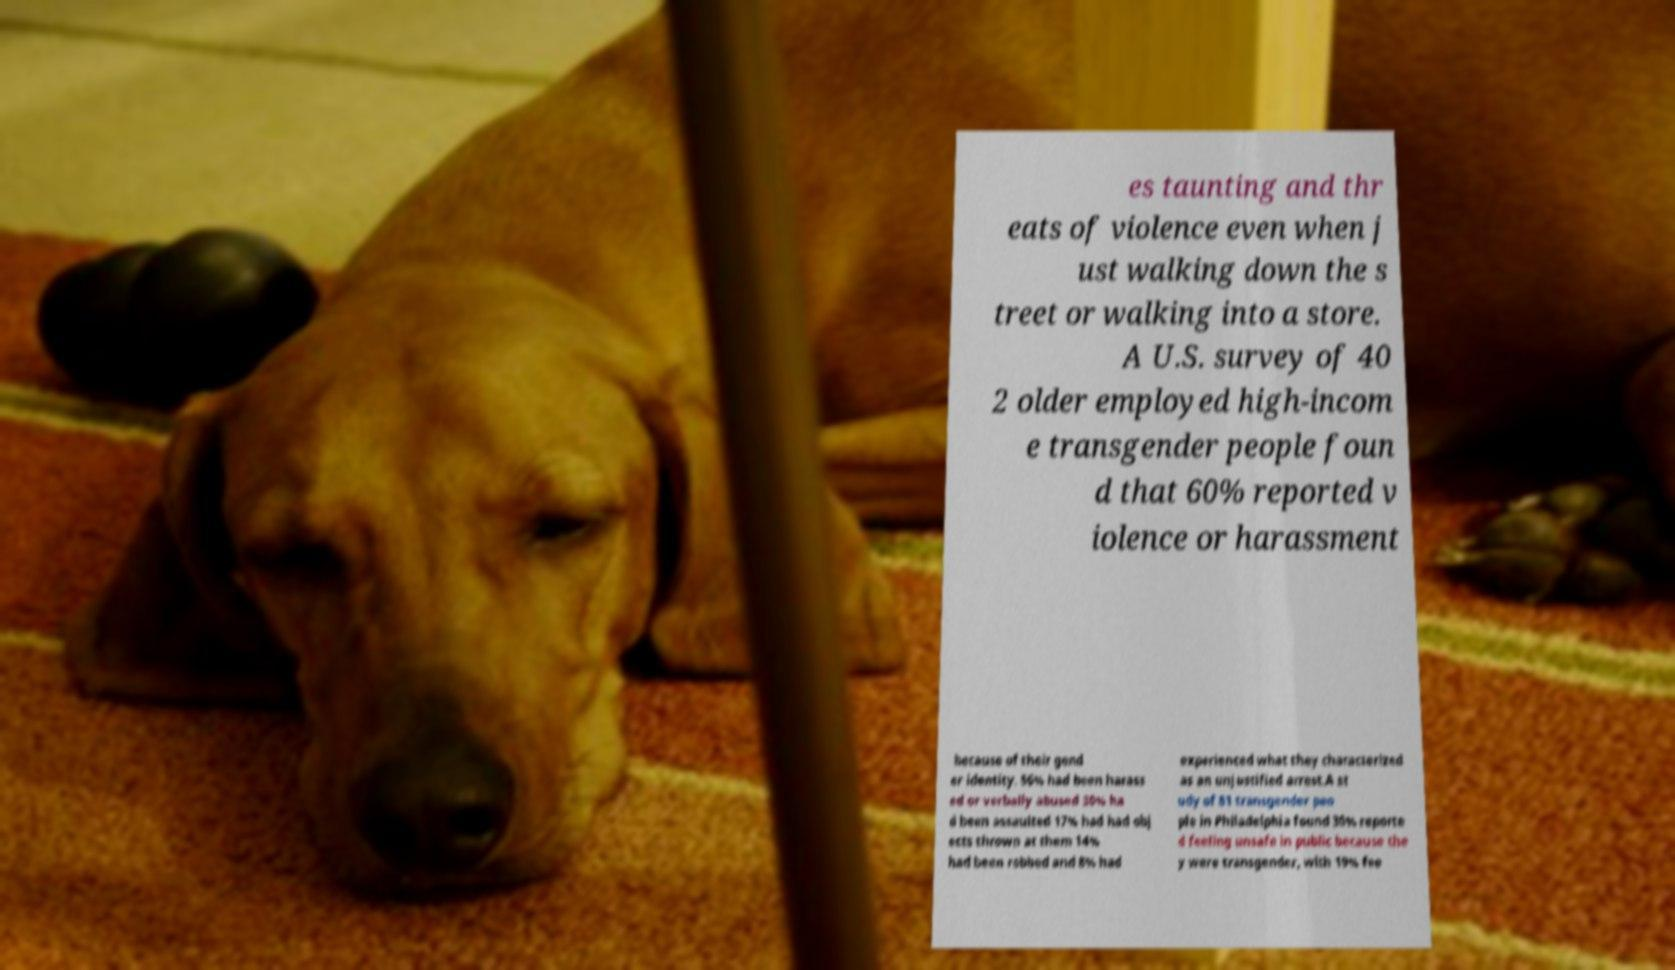Could you extract and type out the text from this image? es taunting and thr eats of violence even when j ust walking down the s treet or walking into a store. A U.S. survey of 40 2 older employed high-incom e transgender people foun d that 60% reported v iolence or harassment because of their gend er identity. 56% had been harass ed or verbally abused 30% ha d been assaulted 17% had had obj ects thrown at them 14% had been robbed and 8% had experienced what they characterized as an unjustified arrest.A st udy of 81 transgender peo ple in Philadelphia found 30% reporte d feeling unsafe in public because the y were transgender, with 19% fee 